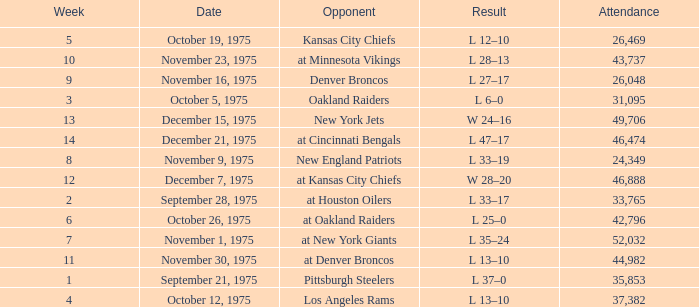What is the average Week when the result was w 28–20, and there were more than 46,888 in attendance? None. 